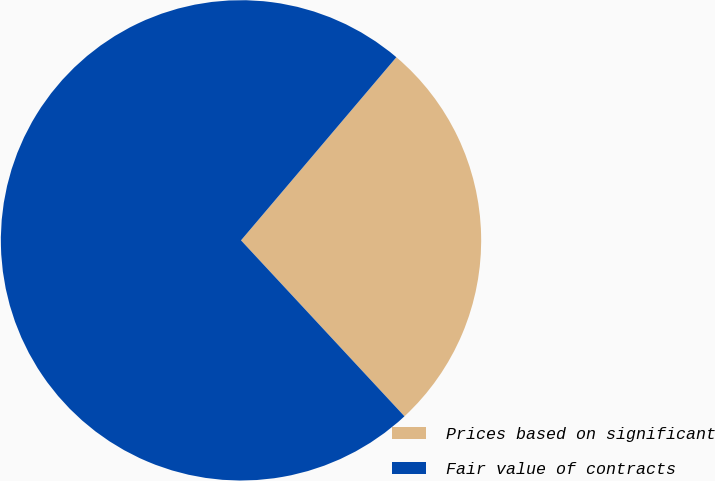<chart> <loc_0><loc_0><loc_500><loc_500><pie_chart><fcel>Prices based on significant<fcel>Fair value of contracts<nl><fcel>26.89%<fcel>73.11%<nl></chart> 